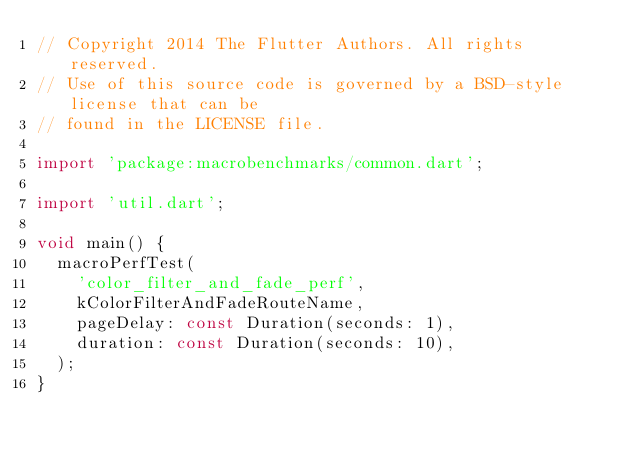Convert code to text. <code><loc_0><loc_0><loc_500><loc_500><_Dart_>// Copyright 2014 The Flutter Authors. All rights reserved.
// Use of this source code is governed by a BSD-style license that can be
// found in the LICENSE file.

import 'package:macrobenchmarks/common.dart';

import 'util.dart';

void main() {
  macroPerfTest(
    'color_filter_and_fade_perf',
    kColorFilterAndFadeRouteName,
    pageDelay: const Duration(seconds: 1),
    duration: const Duration(seconds: 10),
  );
}
</code> 